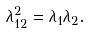<formula> <loc_0><loc_0><loc_500><loc_500>\lambda _ { 1 2 } ^ { 2 } = \lambda _ { 1 } \lambda _ { 2 } .</formula> 